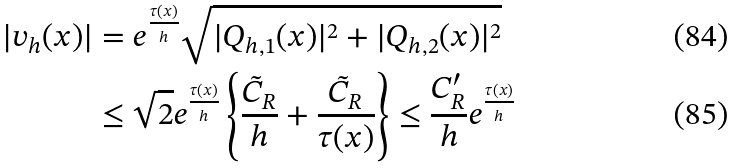Convert formula to latex. <formula><loc_0><loc_0><loc_500><loc_500>| v _ { h } ( x ) | & = e ^ { \frac { \tau ( x ) } { h } } \sqrt { | Q _ { h , 1 } ( x ) | ^ { 2 } + | Q _ { h , 2 } ( x ) | ^ { 2 } } \\ & \leq \sqrt { 2 } e ^ { \frac { \tau ( x ) } { h } } \left \{ \frac { \tilde { C } _ { R } } { h } + \frac { \tilde { C } _ { R } } { \tau ( x ) } \right \} \leq \frac { C ^ { \prime } _ { R } } { h } e ^ { \frac { \tau ( x ) } { h } }</formula> 